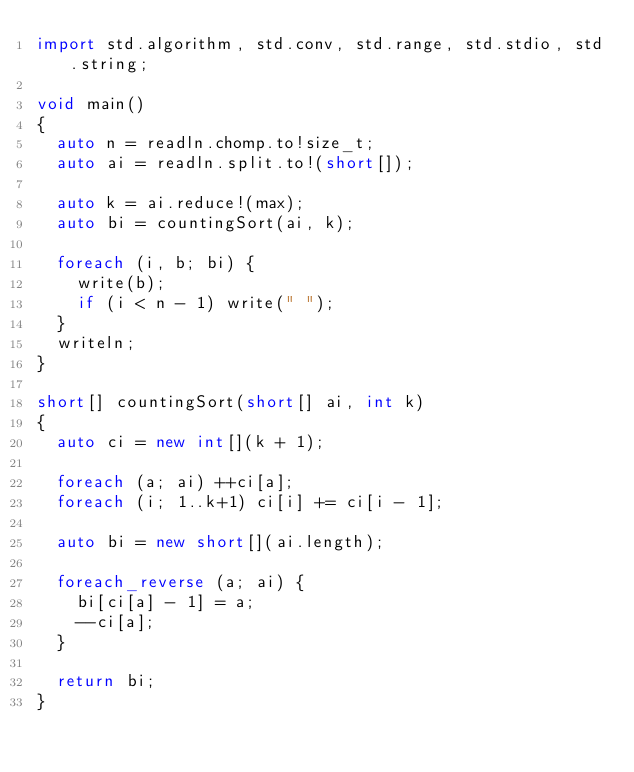Convert code to text. <code><loc_0><loc_0><loc_500><loc_500><_D_>import std.algorithm, std.conv, std.range, std.stdio, std.string;

void main()
{
  auto n = readln.chomp.to!size_t;
  auto ai = readln.split.to!(short[]);

  auto k = ai.reduce!(max);
  auto bi = countingSort(ai, k);

  foreach (i, b; bi) {
    write(b);
    if (i < n - 1) write(" ");
  }
  writeln;
}

short[] countingSort(short[] ai, int k)
{
  auto ci = new int[](k + 1);

  foreach (a; ai) ++ci[a];
  foreach (i; 1..k+1) ci[i] += ci[i - 1];

  auto bi = new short[](ai.length);

  foreach_reverse (a; ai) {
    bi[ci[a] - 1] = a;
    --ci[a];
  }

  return bi;
}</code> 